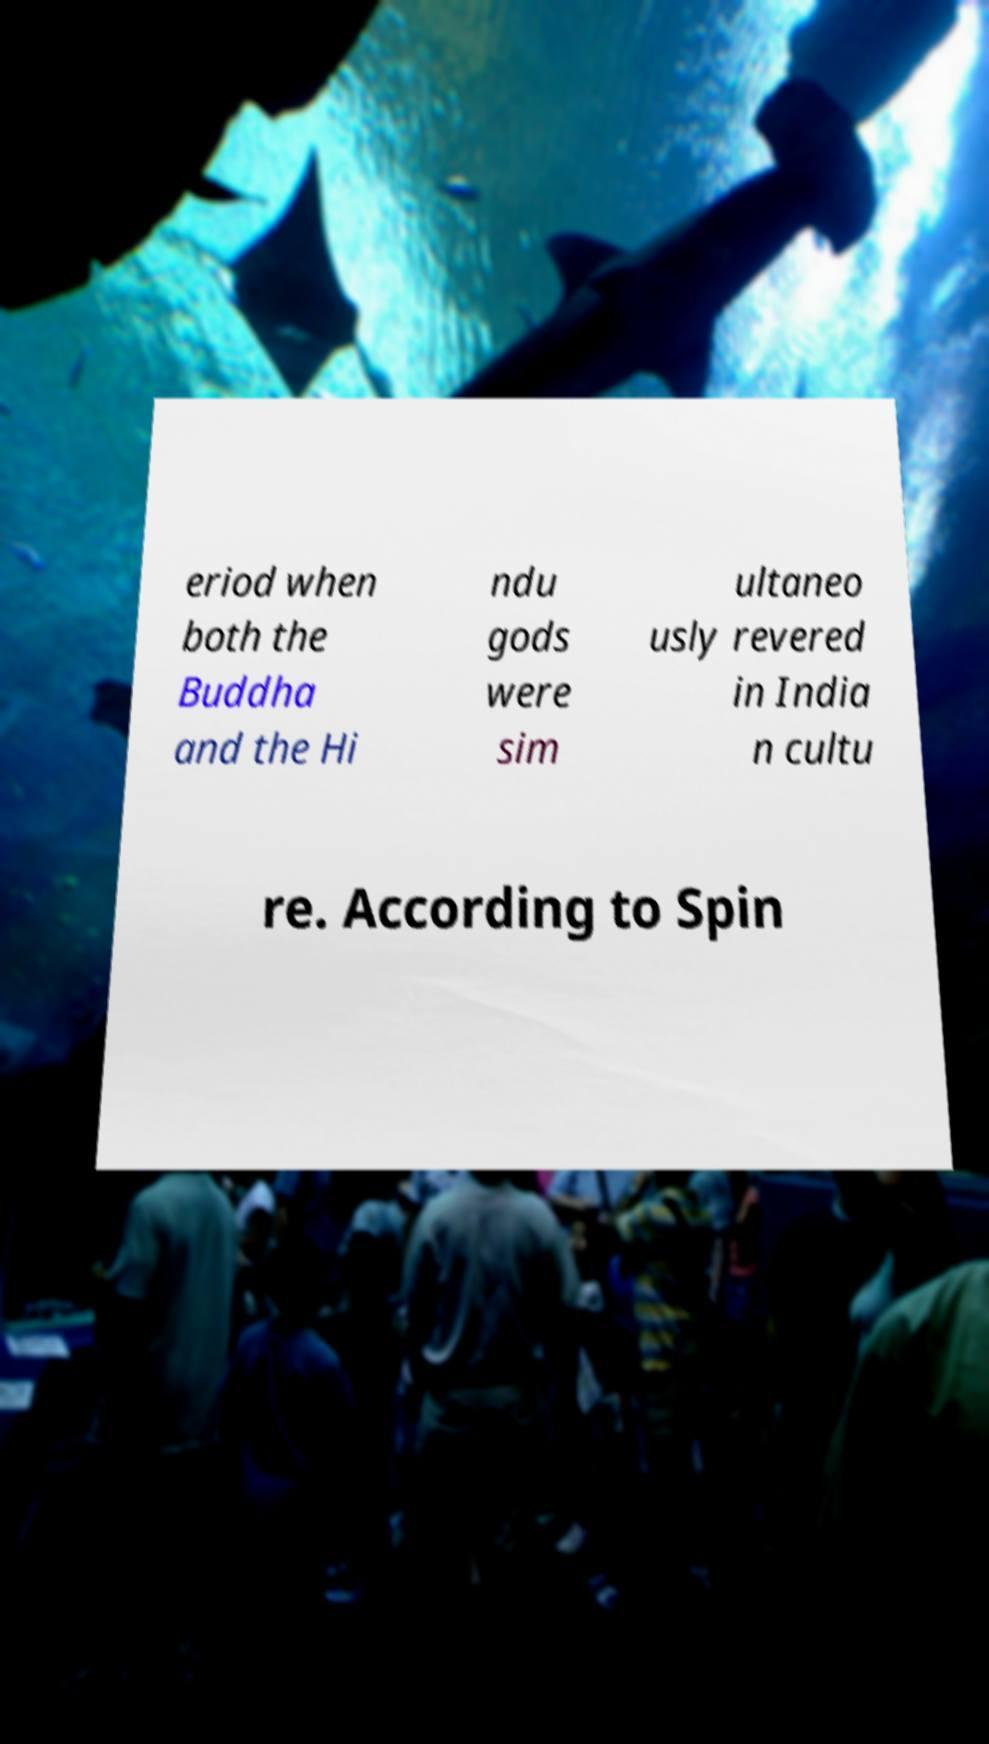Please read and relay the text visible in this image. What does it say? eriod when both the Buddha and the Hi ndu gods were sim ultaneo usly revered in India n cultu re. According to Spin 